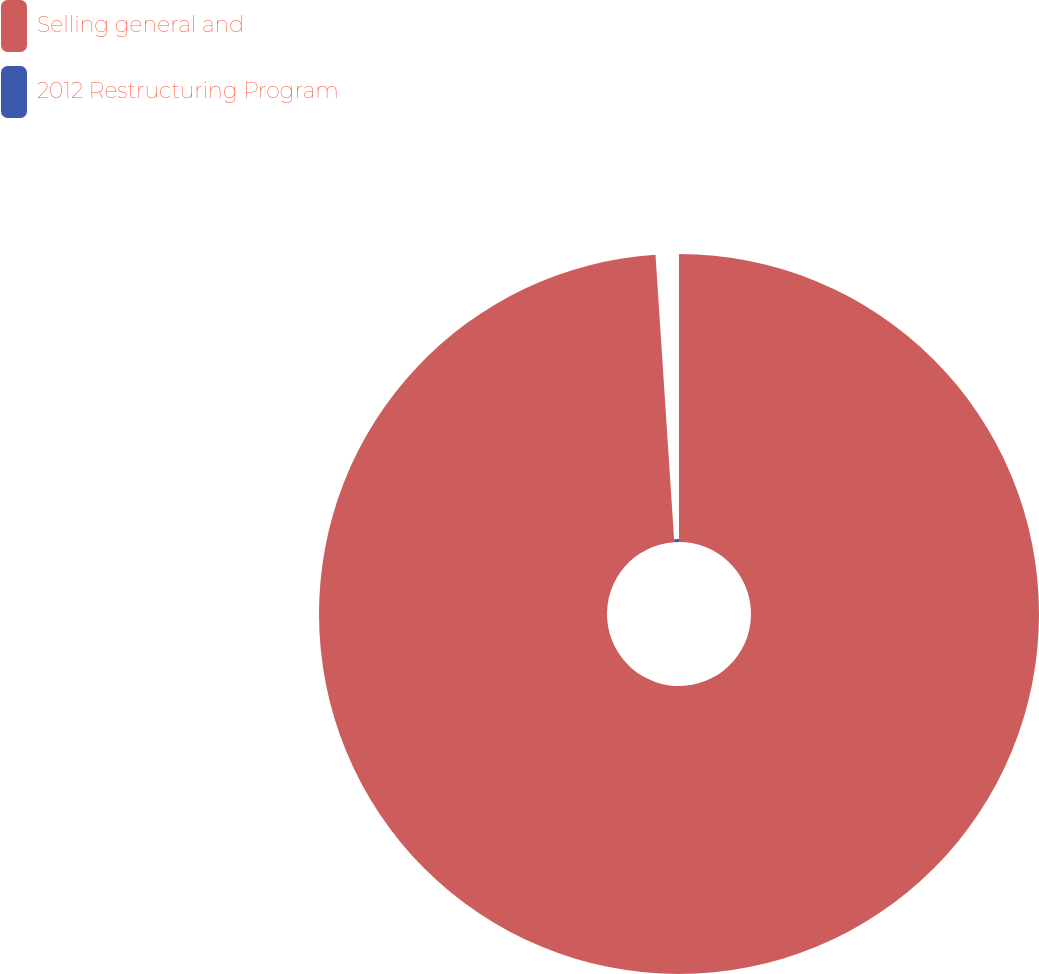<chart> <loc_0><loc_0><loc_500><loc_500><pie_chart><fcel>Selling general and<fcel>2012 Restructuring Program<nl><fcel>98.96%<fcel>1.04%<nl></chart> 